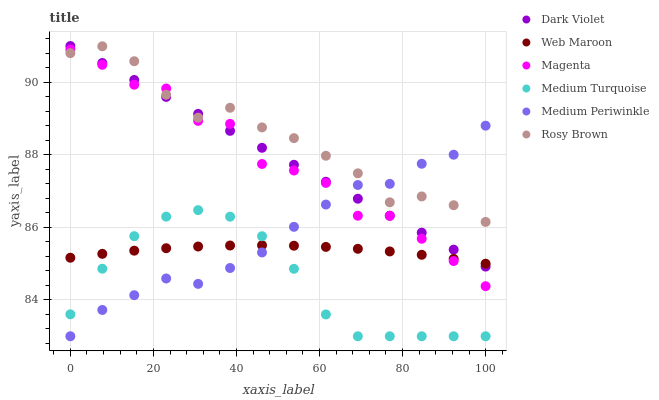Does Medium Turquoise have the minimum area under the curve?
Answer yes or no. Yes. Does Rosy Brown have the maximum area under the curve?
Answer yes or no. Yes. Does Medium Periwinkle have the minimum area under the curve?
Answer yes or no. No. Does Medium Periwinkle have the maximum area under the curve?
Answer yes or no. No. Is Dark Violet the smoothest?
Answer yes or no. Yes. Is Magenta the roughest?
Answer yes or no. Yes. Is Rosy Brown the smoothest?
Answer yes or no. No. Is Rosy Brown the roughest?
Answer yes or no. No. Does Medium Periwinkle have the lowest value?
Answer yes or no. Yes. Does Rosy Brown have the lowest value?
Answer yes or no. No. Does Dark Violet have the highest value?
Answer yes or no. Yes. Does Rosy Brown have the highest value?
Answer yes or no. No. Is Medium Turquoise less than Dark Violet?
Answer yes or no. Yes. Is Magenta greater than Medium Turquoise?
Answer yes or no. Yes. Does Medium Periwinkle intersect Web Maroon?
Answer yes or no. Yes. Is Medium Periwinkle less than Web Maroon?
Answer yes or no. No. Is Medium Periwinkle greater than Web Maroon?
Answer yes or no. No. Does Medium Turquoise intersect Dark Violet?
Answer yes or no. No. 